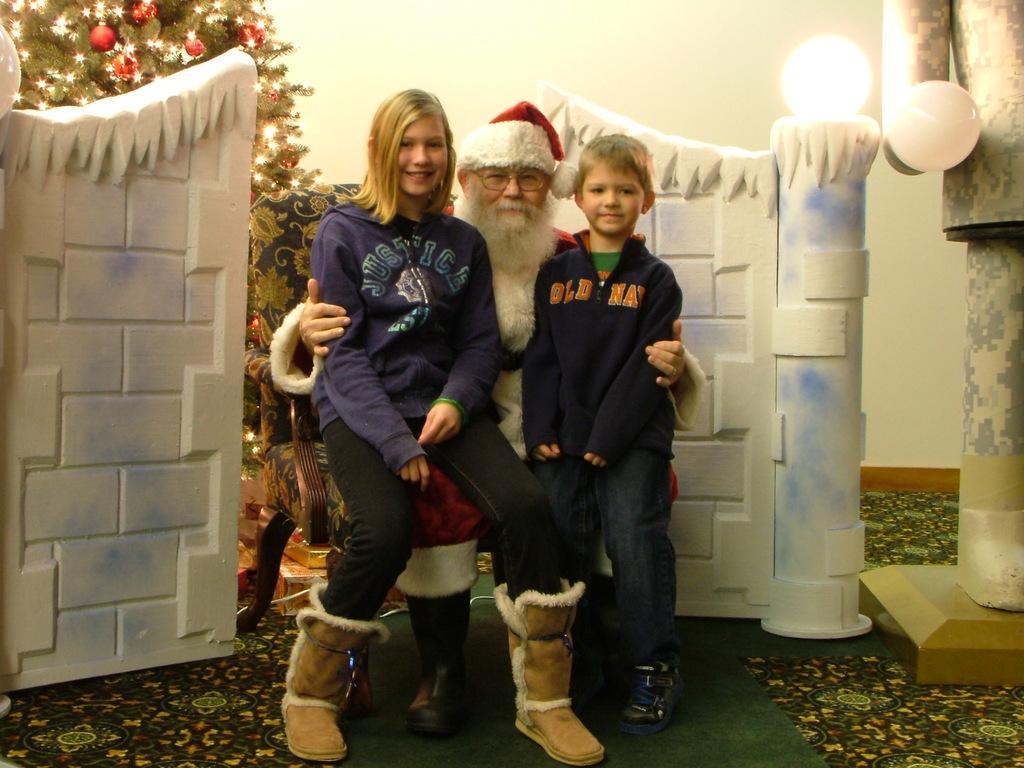Could you give a brief overview of what you see in this image? In this image I can see a man is in Christmas grandfather, beside him a beautiful girl is there, sitting on him, she wore blue color sweater and a little boy is standing near to this man. On the left side there is a Christmas tree decorated. On the right side there is a light. 